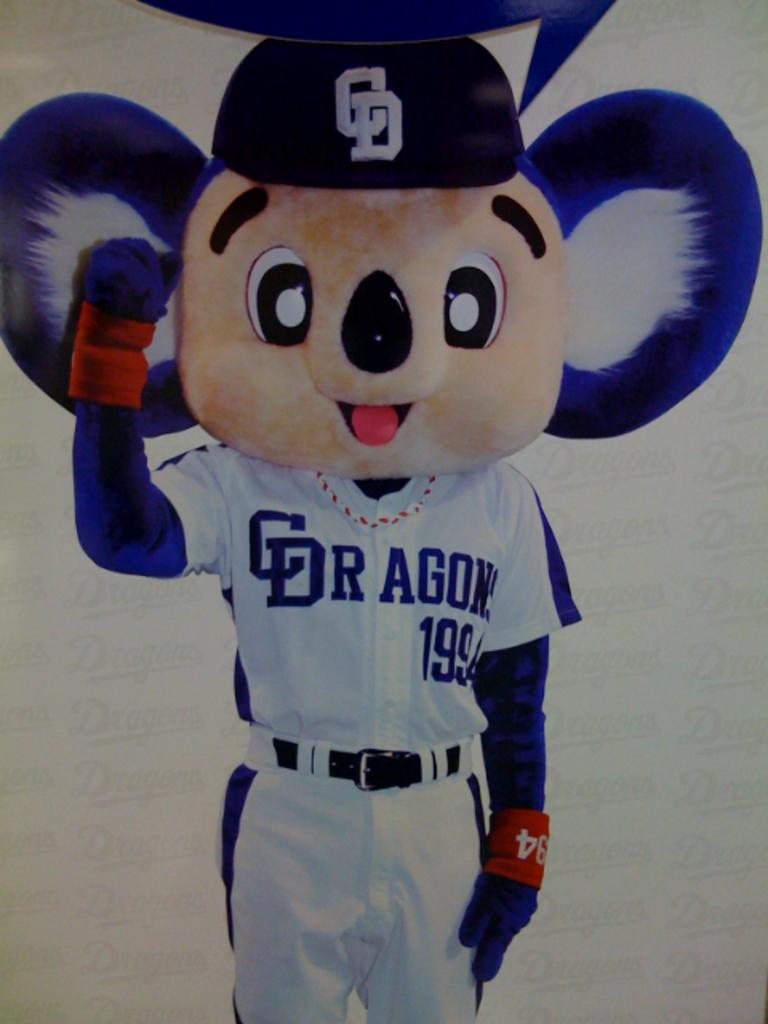<image>
Provide a brief description of the given image. A shirt that has the wording C dragon 1994 on it. 